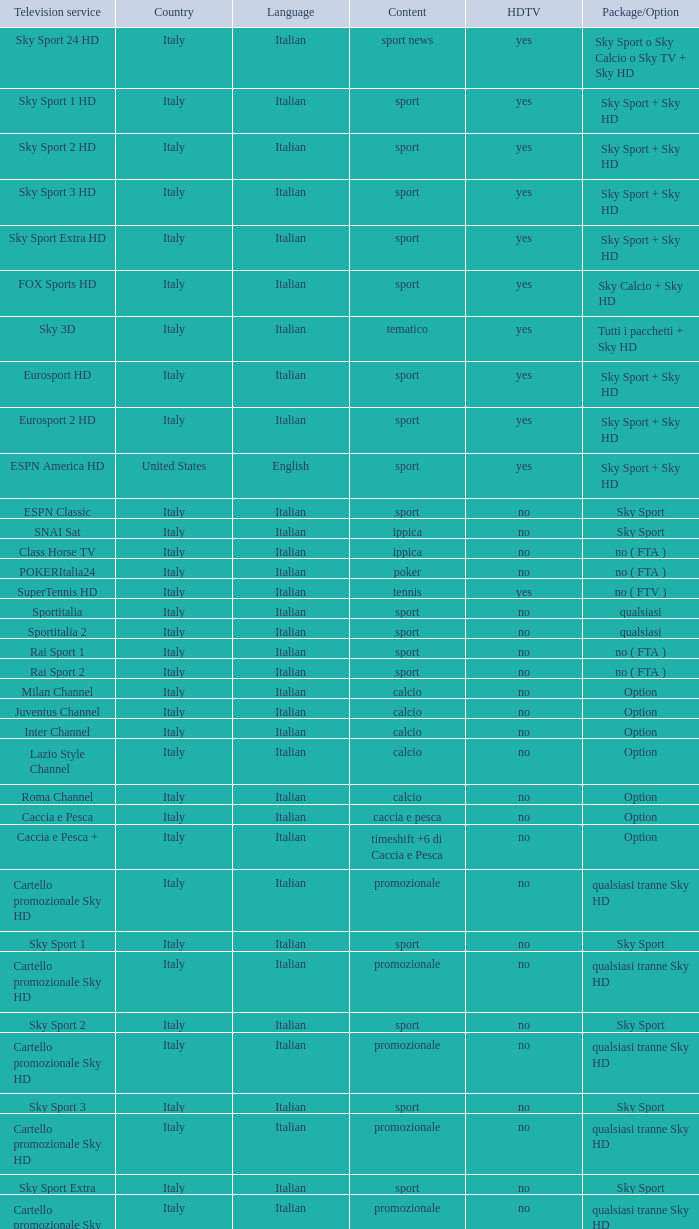When the television service is eurosport 2, what country does it belong to? Italy. 